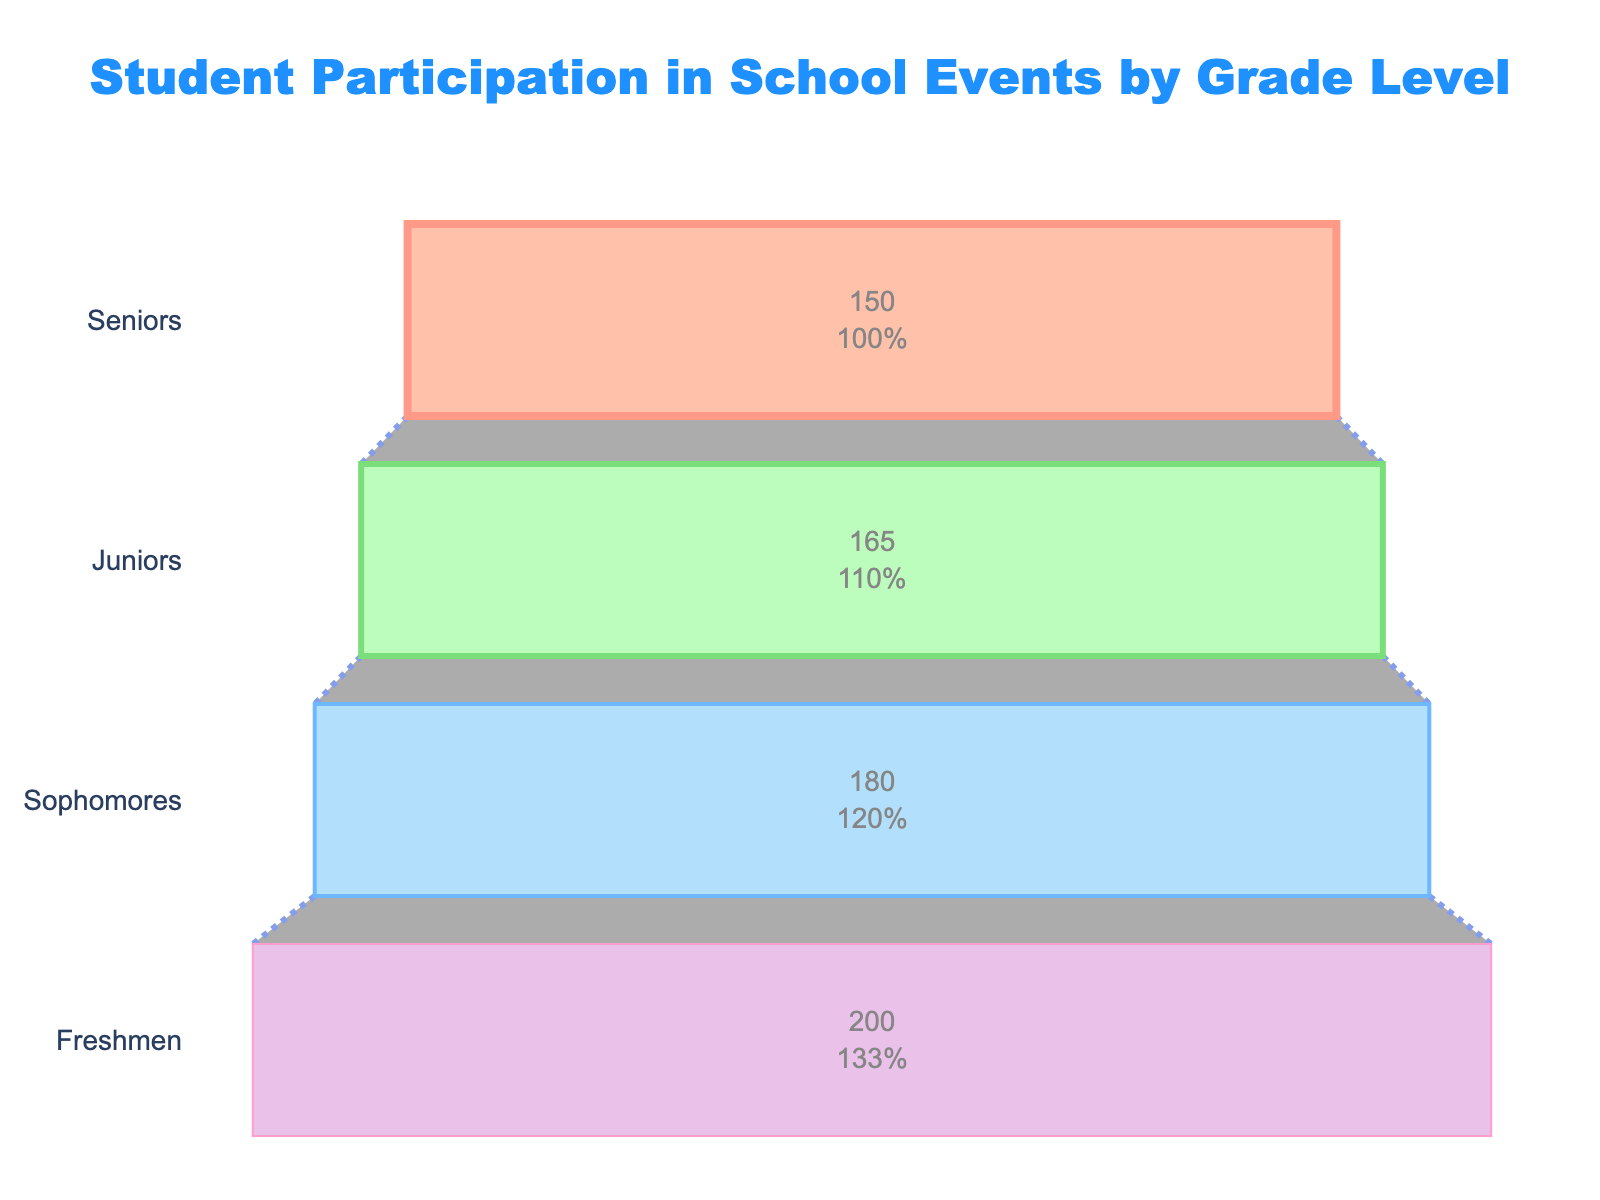What is the title of the figure? The title is prominently displayed at the top of the figure, indicating what the data visualization is about.
Answer: Student Participation in School Events by Grade Level Which grade level has the highest number of students? By observing the funnel chart, the longest bar represents the grade with the highest number of students.
Answer: Freshmen What is the participation rate for Sophomores? The participation rate is directly labeled on the funnel chart's bar for Sophomores.
Answer: 78% How many students participate in school events for Juniors? First, get the participation rate for Juniors which is 85%. Then, calculate 85% of the number of junior students (165). 0.85 * 165 = 140.25, rounded to the nearest whole number is 140.
Answer: 140 Compare the participation rates between Seniors and Freshmen. Which grade level has a higher participation rate, and by how much? Participation rates for Seniors and Freshmen are 92% and 70%, respectively. Subtract the lower rate from the higher rate to find the difference (92% - 70% = 22%).
Answer: Seniors by 22% What is the combined participation rate for Sophomores and Juniors? To find the combined participation rate, average the rates of Sophomores and Juniors. (78% + 85%) / 2 = 81.5%
Answer: 81.5% Which grade level has the lowest participation rate? The shortest bar on the funnel chart indicates the grade with the lowest participation rate, which is Freshmen.
Answer: Freshmen How does the number of participating students change from Juniors to Seniors? Calculate the number of participating students for each grade: 85% of 165 for Juniors (0.85 * 165 = 140.25 ≈ 140) and 92% of 150 for Seniors (0.92 * 150 = 138). Then find the difference 140 - 138 = 2.
Answer: Decreases by 2 What is the overall participation rate for the entire school if you average the rates by grade? To find the overall participation rate, average the participation rates of all grades: (92% + 85% + 78% + 70%) / 4 = 81.25%
Answer: 81.25% In which grade does participation in school events decrease the most compared to the previous grade? Calculate the difference in participation rates between consecutive grades. Compare these differences: Juniors to Sophomores (85% - 78% = 7%), Sophomores to Freshmen (78% - 70% = 8%), and Seniors to Juniors (92% - 85% = 7%). The largest decrease is from Sophomores to Freshmen (78% - 70% = 8%).
Answer: From Sophomores to Freshmen by 8% 